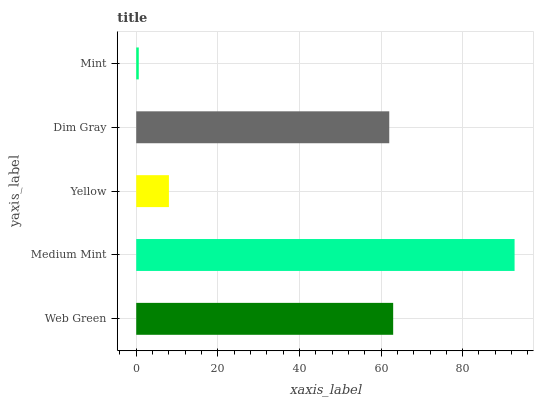Is Mint the minimum?
Answer yes or no. Yes. Is Medium Mint the maximum?
Answer yes or no. Yes. Is Yellow the minimum?
Answer yes or no. No. Is Yellow the maximum?
Answer yes or no. No. Is Medium Mint greater than Yellow?
Answer yes or no. Yes. Is Yellow less than Medium Mint?
Answer yes or no. Yes. Is Yellow greater than Medium Mint?
Answer yes or no. No. Is Medium Mint less than Yellow?
Answer yes or no. No. Is Dim Gray the high median?
Answer yes or no. Yes. Is Dim Gray the low median?
Answer yes or no. Yes. Is Medium Mint the high median?
Answer yes or no. No. Is Web Green the low median?
Answer yes or no. No. 